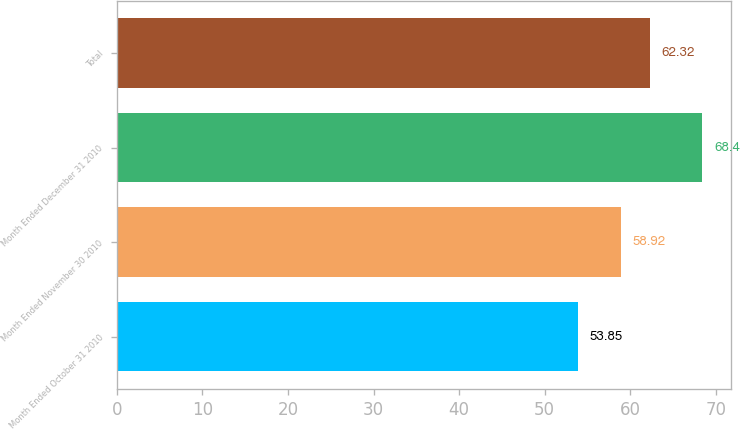<chart> <loc_0><loc_0><loc_500><loc_500><bar_chart><fcel>Month Ended October 31 2010<fcel>Month Ended November 30 2010<fcel>Month Ended December 31 2010<fcel>Total<nl><fcel>53.85<fcel>58.92<fcel>68.4<fcel>62.32<nl></chart> 